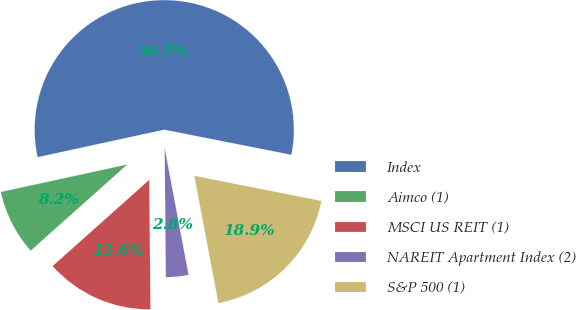Convert chart. <chart><loc_0><loc_0><loc_500><loc_500><pie_chart><fcel>Index<fcel>Aimco (1)<fcel>MSCI US REIT (1)<fcel>NAREIT Apartment Index (2)<fcel>S&P 500 (1)<nl><fcel>56.52%<fcel>8.19%<fcel>13.56%<fcel>2.82%<fcel>18.93%<nl></chart> 